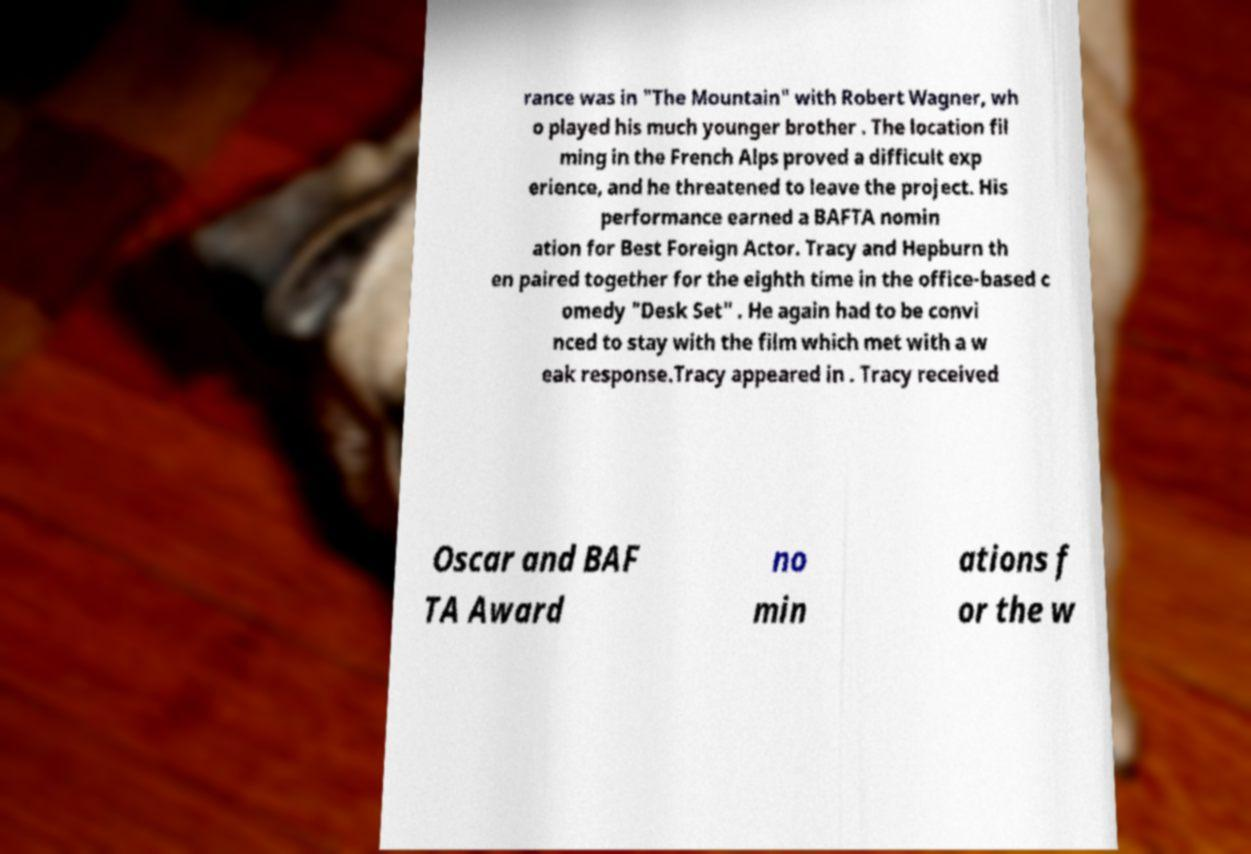For documentation purposes, I need the text within this image transcribed. Could you provide that? rance was in "The Mountain" with Robert Wagner, wh o played his much younger brother . The location fil ming in the French Alps proved a difficult exp erience, and he threatened to leave the project. His performance earned a BAFTA nomin ation for Best Foreign Actor. Tracy and Hepburn th en paired together for the eighth time in the office-based c omedy "Desk Set" . He again had to be convi nced to stay with the film which met with a w eak response.Tracy appeared in . Tracy received Oscar and BAF TA Award no min ations f or the w 